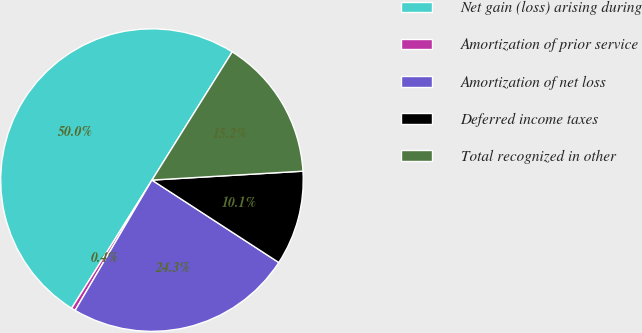<chart> <loc_0><loc_0><loc_500><loc_500><pie_chart><fcel>Net gain (loss) arising during<fcel>Amortization of prior service<fcel>Amortization of net loss<fcel>Deferred income taxes<fcel>Total recognized in other<nl><fcel>50.0%<fcel>0.43%<fcel>24.31%<fcel>10.11%<fcel>15.16%<nl></chart> 